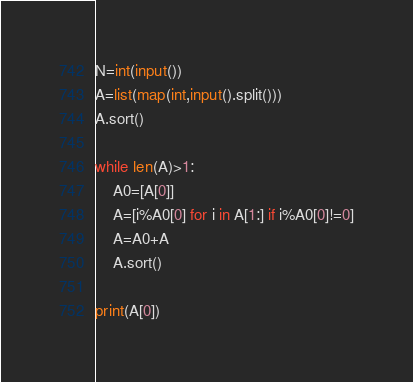Convert code to text. <code><loc_0><loc_0><loc_500><loc_500><_Python_>N=int(input())
A=list(map(int,input().split()))
A.sort()

while len(A)>1:
    A0=[A[0]]
    A=[i%A0[0] for i in A[1:] if i%A0[0]!=0]
    A=A0+A
    A.sort()

print(A[0])</code> 